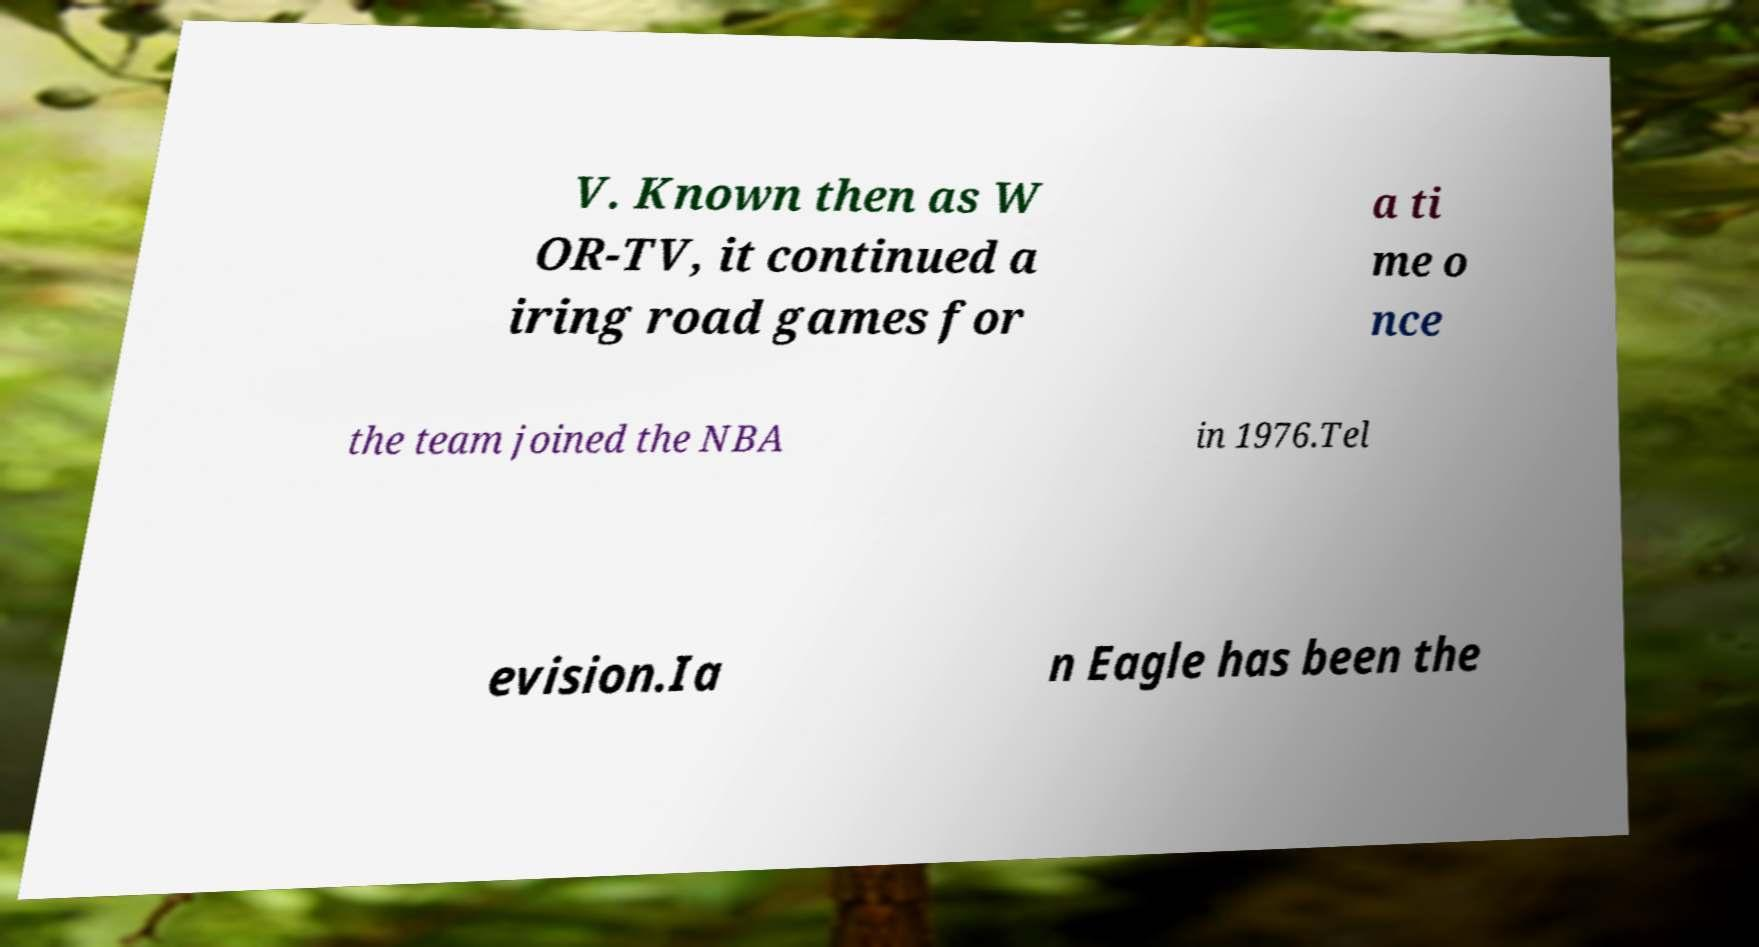Please identify and transcribe the text found in this image. V. Known then as W OR-TV, it continued a iring road games for a ti me o nce the team joined the NBA in 1976.Tel evision.Ia n Eagle has been the 